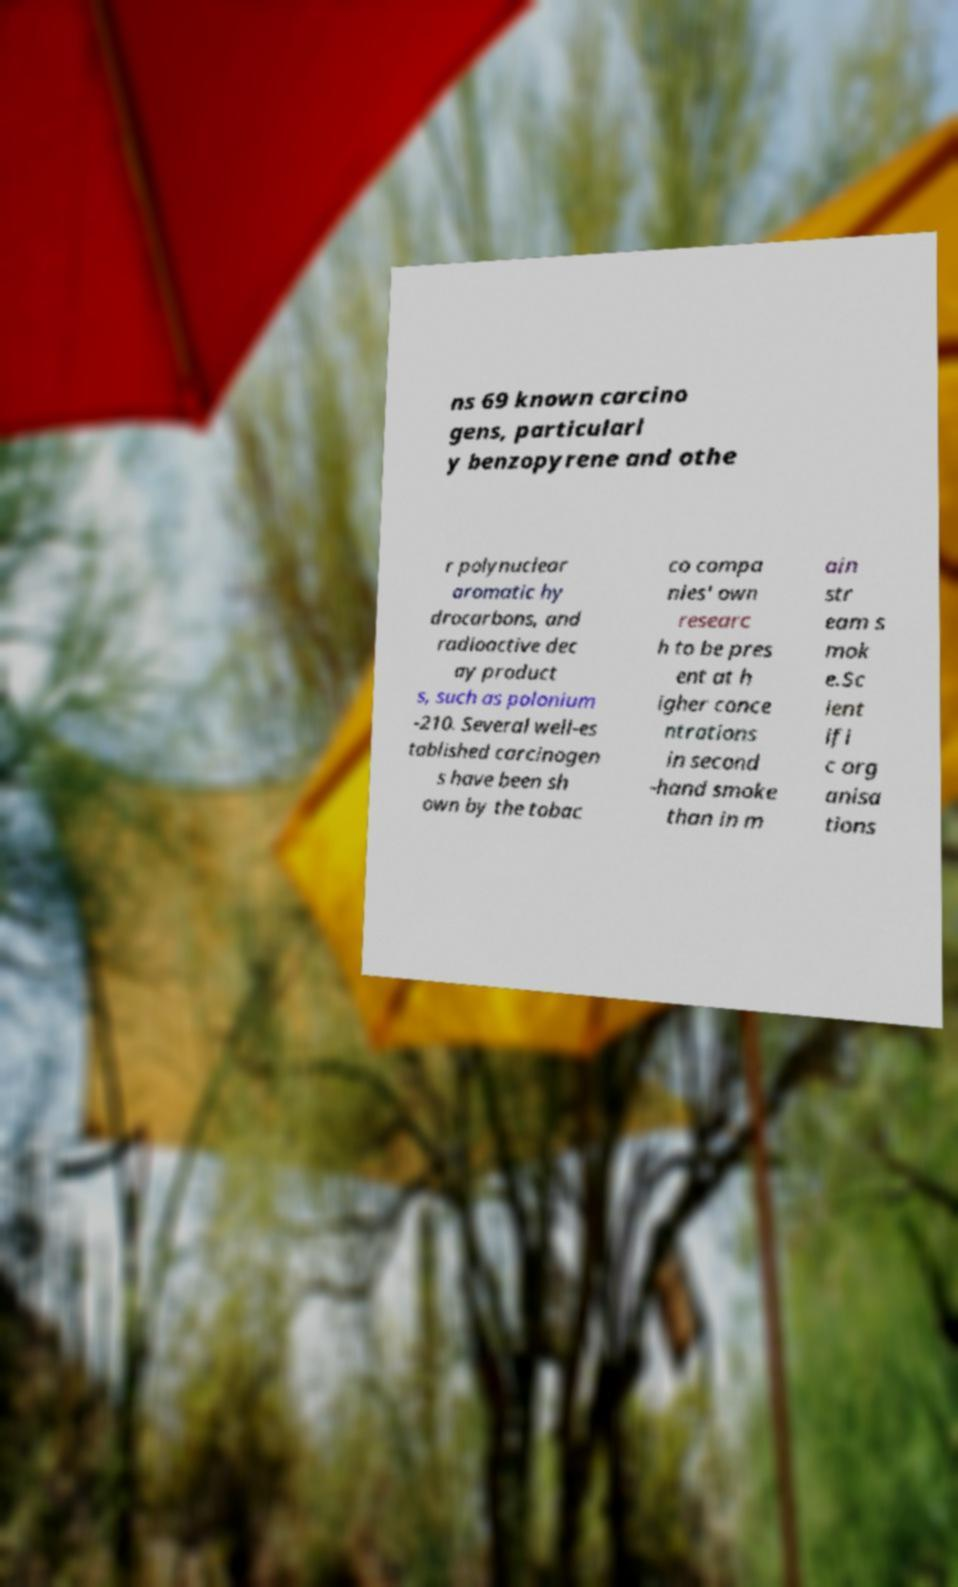Could you extract and type out the text from this image? ns 69 known carcino gens, particularl y benzopyrene and othe r polynuclear aromatic hy drocarbons, and radioactive dec ay product s, such as polonium -210. Several well-es tablished carcinogen s have been sh own by the tobac co compa nies' own researc h to be pres ent at h igher conce ntrations in second -hand smoke than in m ain str eam s mok e.Sc ient ifi c org anisa tions 